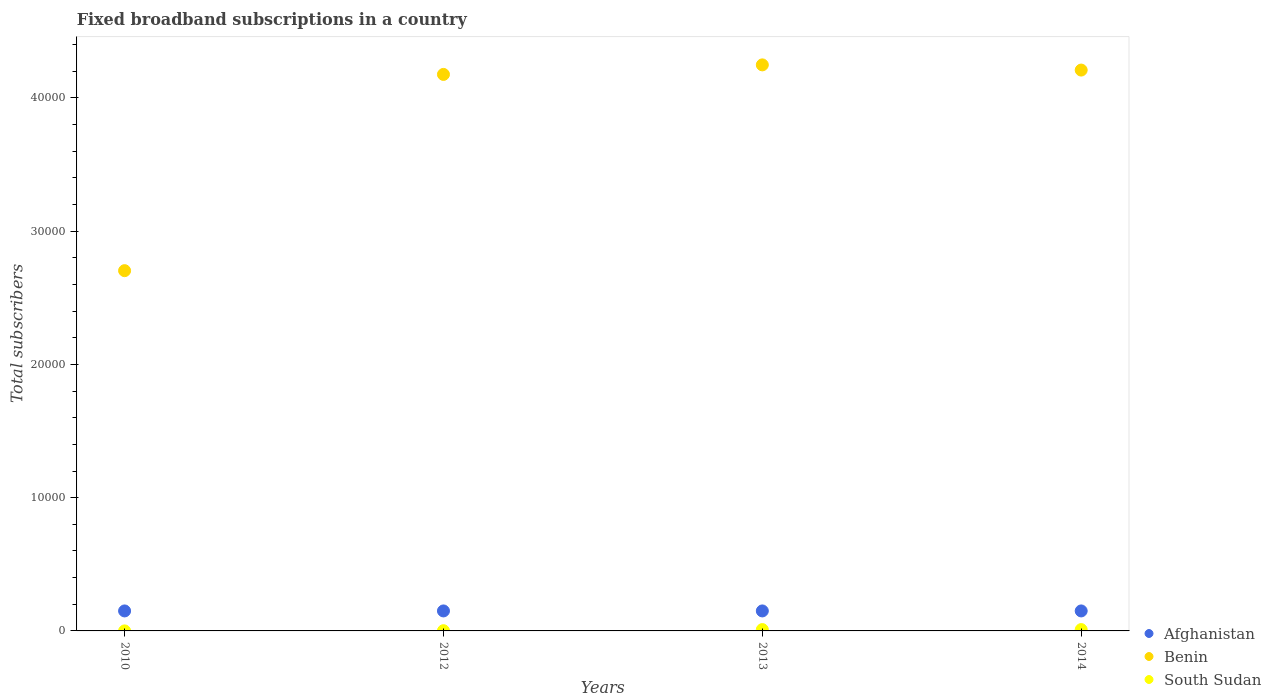How many different coloured dotlines are there?
Offer a very short reply. 3. Is the number of dotlines equal to the number of legend labels?
Give a very brief answer. Yes. Across all years, what is the maximum number of broadband subscriptions in Afghanistan?
Offer a very short reply. 1500. Across all years, what is the minimum number of broadband subscriptions in Afghanistan?
Provide a succinct answer. 1500. In which year was the number of broadband subscriptions in South Sudan minimum?
Provide a succinct answer. 2010. What is the total number of broadband subscriptions in South Sudan in the graph?
Your answer should be compact. 219. What is the difference between the number of broadband subscriptions in Afghanistan in 2012 and that in 2013?
Your answer should be very brief. 0. What is the difference between the number of broadband subscriptions in South Sudan in 2013 and the number of broadband subscriptions in Afghanistan in 2010?
Give a very brief answer. -1400. What is the average number of broadband subscriptions in South Sudan per year?
Make the answer very short. 54.75. In the year 2013, what is the difference between the number of broadband subscriptions in South Sudan and number of broadband subscriptions in Afghanistan?
Offer a very short reply. -1400. What is the ratio of the number of broadband subscriptions in Benin in 2013 to that in 2014?
Provide a succinct answer. 1.01. Is the difference between the number of broadband subscriptions in South Sudan in 2010 and 2012 greater than the difference between the number of broadband subscriptions in Afghanistan in 2010 and 2012?
Offer a terse response. No. What is the difference between the highest and the lowest number of broadband subscriptions in Benin?
Offer a terse response. 1.54e+04. Does the number of broadband subscriptions in South Sudan monotonically increase over the years?
Offer a terse response. No. Is the number of broadband subscriptions in Benin strictly less than the number of broadband subscriptions in South Sudan over the years?
Give a very brief answer. No. How many dotlines are there?
Give a very brief answer. 3. How many years are there in the graph?
Keep it short and to the point. 4. Does the graph contain any zero values?
Provide a short and direct response. No. Does the graph contain grids?
Your answer should be very brief. No. How are the legend labels stacked?
Give a very brief answer. Vertical. What is the title of the graph?
Offer a very short reply. Fixed broadband subscriptions in a country. What is the label or title of the X-axis?
Your answer should be very brief. Years. What is the label or title of the Y-axis?
Provide a succinct answer. Total subscribers. What is the Total subscribers of Afghanistan in 2010?
Offer a very short reply. 1500. What is the Total subscribers of Benin in 2010?
Give a very brief answer. 2.70e+04. What is the Total subscribers in South Sudan in 2010?
Offer a very short reply. 2. What is the Total subscribers in Afghanistan in 2012?
Make the answer very short. 1500. What is the Total subscribers in Benin in 2012?
Your response must be concise. 4.18e+04. What is the Total subscribers of Afghanistan in 2013?
Ensure brevity in your answer.  1500. What is the Total subscribers in Benin in 2013?
Offer a terse response. 4.25e+04. What is the Total subscribers of South Sudan in 2013?
Your answer should be very brief. 100. What is the Total subscribers of Afghanistan in 2014?
Offer a terse response. 1500. What is the Total subscribers in Benin in 2014?
Give a very brief answer. 4.21e+04. Across all years, what is the maximum Total subscribers in Afghanistan?
Your answer should be compact. 1500. Across all years, what is the maximum Total subscribers in Benin?
Your answer should be compact. 4.25e+04. Across all years, what is the minimum Total subscribers of Afghanistan?
Provide a succinct answer. 1500. Across all years, what is the minimum Total subscribers of Benin?
Offer a very short reply. 2.70e+04. Across all years, what is the minimum Total subscribers in South Sudan?
Provide a succinct answer. 2. What is the total Total subscribers of Afghanistan in the graph?
Keep it short and to the point. 6000. What is the total Total subscribers of Benin in the graph?
Your response must be concise. 1.53e+05. What is the total Total subscribers in South Sudan in the graph?
Your answer should be very brief. 219. What is the difference between the Total subscribers in Afghanistan in 2010 and that in 2012?
Keep it short and to the point. 0. What is the difference between the Total subscribers in Benin in 2010 and that in 2012?
Provide a short and direct response. -1.47e+04. What is the difference between the Total subscribers of Benin in 2010 and that in 2013?
Keep it short and to the point. -1.54e+04. What is the difference between the Total subscribers in South Sudan in 2010 and that in 2013?
Make the answer very short. -98. What is the difference between the Total subscribers of Benin in 2010 and that in 2014?
Your answer should be very brief. -1.51e+04. What is the difference between the Total subscribers in South Sudan in 2010 and that in 2014?
Give a very brief answer. -98. What is the difference between the Total subscribers in Benin in 2012 and that in 2013?
Your answer should be very brief. -716. What is the difference between the Total subscribers in South Sudan in 2012 and that in 2013?
Offer a very short reply. -83. What is the difference between the Total subscribers in Afghanistan in 2012 and that in 2014?
Your answer should be compact. 0. What is the difference between the Total subscribers in Benin in 2012 and that in 2014?
Provide a succinct answer. -326. What is the difference between the Total subscribers of South Sudan in 2012 and that in 2014?
Offer a terse response. -83. What is the difference between the Total subscribers in Benin in 2013 and that in 2014?
Provide a succinct answer. 390. What is the difference between the Total subscribers of Afghanistan in 2010 and the Total subscribers of Benin in 2012?
Make the answer very short. -4.03e+04. What is the difference between the Total subscribers in Afghanistan in 2010 and the Total subscribers in South Sudan in 2012?
Give a very brief answer. 1483. What is the difference between the Total subscribers of Benin in 2010 and the Total subscribers of South Sudan in 2012?
Offer a very short reply. 2.70e+04. What is the difference between the Total subscribers in Afghanistan in 2010 and the Total subscribers in Benin in 2013?
Give a very brief answer. -4.10e+04. What is the difference between the Total subscribers of Afghanistan in 2010 and the Total subscribers of South Sudan in 2013?
Provide a succinct answer. 1400. What is the difference between the Total subscribers in Benin in 2010 and the Total subscribers in South Sudan in 2013?
Your answer should be very brief. 2.69e+04. What is the difference between the Total subscribers in Afghanistan in 2010 and the Total subscribers in Benin in 2014?
Your answer should be very brief. -4.06e+04. What is the difference between the Total subscribers of Afghanistan in 2010 and the Total subscribers of South Sudan in 2014?
Your answer should be very brief. 1400. What is the difference between the Total subscribers of Benin in 2010 and the Total subscribers of South Sudan in 2014?
Provide a succinct answer. 2.69e+04. What is the difference between the Total subscribers in Afghanistan in 2012 and the Total subscribers in Benin in 2013?
Provide a succinct answer. -4.10e+04. What is the difference between the Total subscribers in Afghanistan in 2012 and the Total subscribers in South Sudan in 2013?
Your answer should be compact. 1400. What is the difference between the Total subscribers in Benin in 2012 and the Total subscribers in South Sudan in 2013?
Offer a terse response. 4.17e+04. What is the difference between the Total subscribers of Afghanistan in 2012 and the Total subscribers of Benin in 2014?
Keep it short and to the point. -4.06e+04. What is the difference between the Total subscribers of Afghanistan in 2012 and the Total subscribers of South Sudan in 2014?
Give a very brief answer. 1400. What is the difference between the Total subscribers of Benin in 2012 and the Total subscribers of South Sudan in 2014?
Keep it short and to the point. 4.17e+04. What is the difference between the Total subscribers of Afghanistan in 2013 and the Total subscribers of Benin in 2014?
Your answer should be compact. -4.06e+04. What is the difference between the Total subscribers of Afghanistan in 2013 and the Total subscribers of South Sudan in 2014?
Make the answer very short. 1400. What is the difference between the Total subscribers in Benin in 2013 and the Total subscribers in South Sudan in 2014?
Your answer should be very brief. 4.24e+04. What is the average Total subscribers of Afghanistan per year?
Make the answer very short. 1500. What is the average Total subscribers of Benin per year?
Your response must be concise. 3.83e+04. What is the average Total subscribers of South Sudan per year?
Your answer should be compact. 54.75. In the year 2010, what is the difference between the Total subscribers of Afghanistan and Total subscribers of Benin?
Make the answer very short. -2.55e+04. In the year 2010, what is the difference between the Total subscribers of Afghanistan and Total subscribers of South Sudan?
Offer a very short reply. 1498. In the year 2010, what is the difference between the Total subscribers of Benin and Total subscribers of South Sudan?
Keep it short and to the point. 2.70e+04. In the year 2012, what is the difference between the Total subscribers of Afghanistan and Total subscribers of Benin?
Make the answer very short. -4.03e+04. In the year 2012, what is the difference between the Total subscribers in Afghanistan and Total subscribers in South Sudan?
Give a very brief answer. 1483. In the year 2012, what is the difference between the Total subscribers in Benin and Total subscribers in South Sudan?
Offer a terse response. 4.17e+04. In the year 2013, what is the difference between the Total subscribers in Afghanistan and Total subscribers in Benin?
Provide a short and direct response. -4.10e+04. In the year 2013, what is the difference between the Total subscribers in Afghanistan and Total subscribers in South Sudan?
Your answer should be compact. 1400. In the year 2013, what is the difference between the Total subscribers in Benin and Total subscribers in South Sudan?
Offer a very short reply. 4.24e+04. In the year 2014, what is the difference between the Total subscribers of Afghanistan and Total subscribers of Benin?
Make the answer very short. -4.06e+04. In the year 2014, what is the difference between the Total subscribers of Afghanistan and Total subscribers of South Sudan?
Your answer should be compact. 1400. In the year 2014, what is the difference between the Total subscribers of Benin and Total subscribers of South Sudan?
Offer a terse response. 4.20e+04. What is the ratio of the Total subscribers of Afghanistan in 2010 to that in 2012?
Offer a very short reply. 1. What is the ratio of the Total subscribers in Benin in 2010 to that in 2012?
Offer a very short reply. 0.65. What is the ratio of the Total subscribers in South Sudan in 2010 to that in 2012?
Offer a very short reply. 0.12. What is the ratio of the Total subscribers in Afghanistan in 2010 to that in 2013?
Provide a succinct answer. 1. What is the ratio of the Total subscribers of Benin in 2010 to that in 2013?
Your answer should be compact. 0.64. What is the ratio of the Total subscribers of Benin in 2010 to that in 2014?
Provide a short and direct response. 0.64. What is the ratio of the Total subscribers of Afghanistan in 2012 to that in 2013?
Keep it short and to the point. 1. What is the ratio of the Total subscribers of Benin in 2012 to that in 2013?
Your response must be concise. 0.98. What is the ratio of the Total subscribers of South Sudan in 2012 to that in 2013?
Keep it short and to the point. 0.17. What is the ratio of the Total subscribers of Benin in 2012 to that in 2014?
Provide a succinct answer. 0.99. What is the ratio of the Total subscribers of South Sudan in 2012 to that in 2014?
Offer a terse response. 0.17. What is the ratio of the Total subscribers in Afghanistan in 2013 to that in 2014?
Give a very brief answer. 1. What is the ratio of the Total subscribers in Benin in 2013 to that in 2014?
Make the answer very short. 1.01. What is the difference between the highest and the second highest Total subscribers in Benin?
Keep it short and to the point. 390. What is the difference between the highest and the lowest Total subscribers of Benin?
Your answer should be compact. 1.54e+04. 